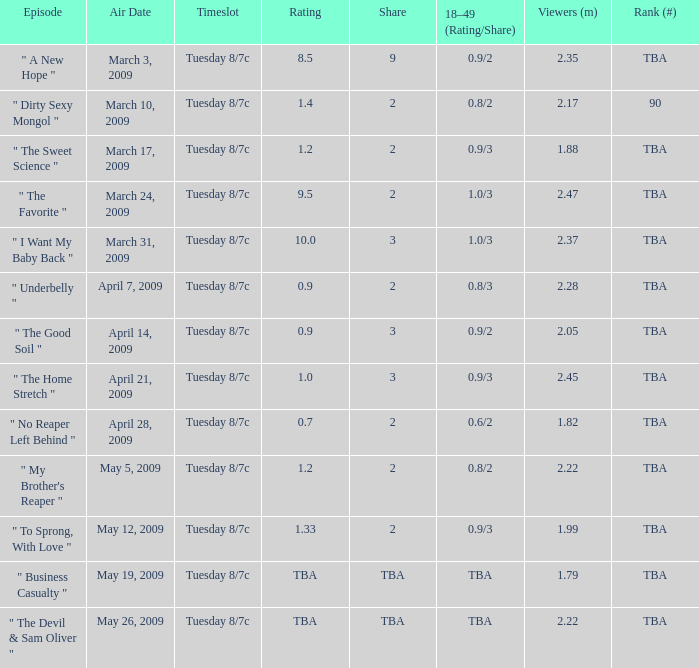What is the fraction of the 18-49 (rating/share) of 2.0. 